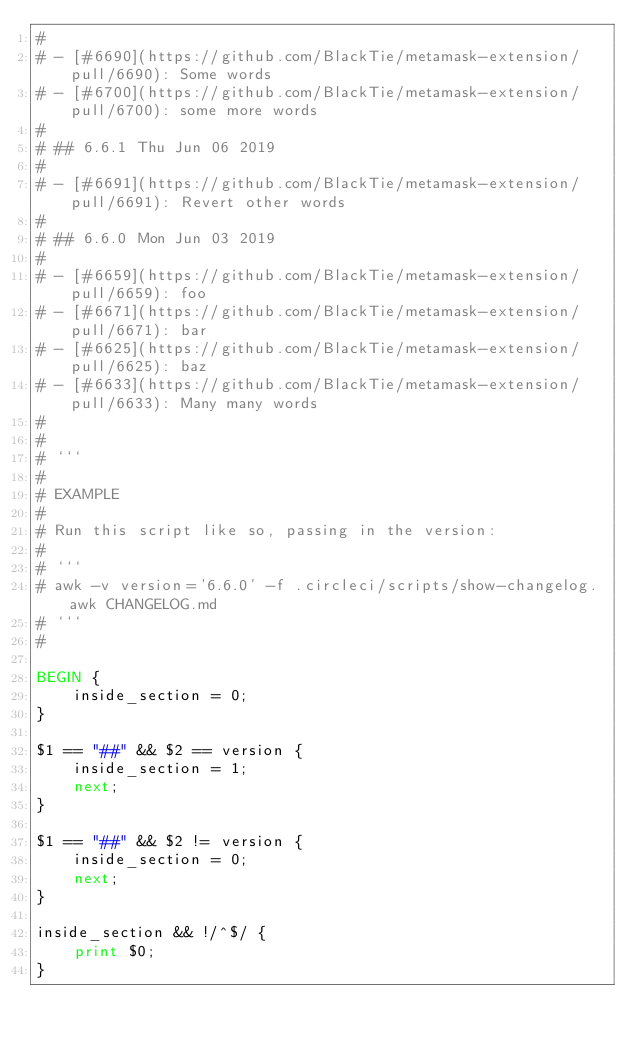<code> <loc_0><loc_0><loc_500><loc_500><_Awk_>#
# - [#6690](https://github.com/BlackTie/metamask-extension/pull/6690): Some words
# - [#6700](https://github.com/BlackTie/metamask-extension/pull/6700): some more words
#
# ## 6.6.1 Thu Jun 06 2019
#
# - [#6691](https://github.com/BlackTie/metamask-extension/pull/6691): Revert other words
#
# ## 6.6.0 Mon Jun 03 2019
#
# - [#6659](https://github.com/BlackTie/metamask-extension/pull/6659): foo
# - [#6671](https://github.com/BlackTie/metamask-extension/pull/6671): bar
# - [#6625](https://github.com/BlackTie/metamask-extension/pull/6625): baz
# - [#6633](https://github.com/BlackTie/metamask-extension/pull/6633): Many many words
#
#
# ```
#
# EXAMPLE
#
# Run this script like so, passing in the version:
#
# ```
# awk -v version='6.6.0' -f .circleci/scripts/show-changelog.awk CHANGELOG.md
# ```
#

BEGIN {
    inside_section = 0;
}

$1 == "##" && $2 == version {
    inside_section = 1;
    next;
}

$1 == "##" && $2 != version {
    inside_section = 0;
    next;
}

inside_section && !/^$/ {
    print $0;
}
</code> 